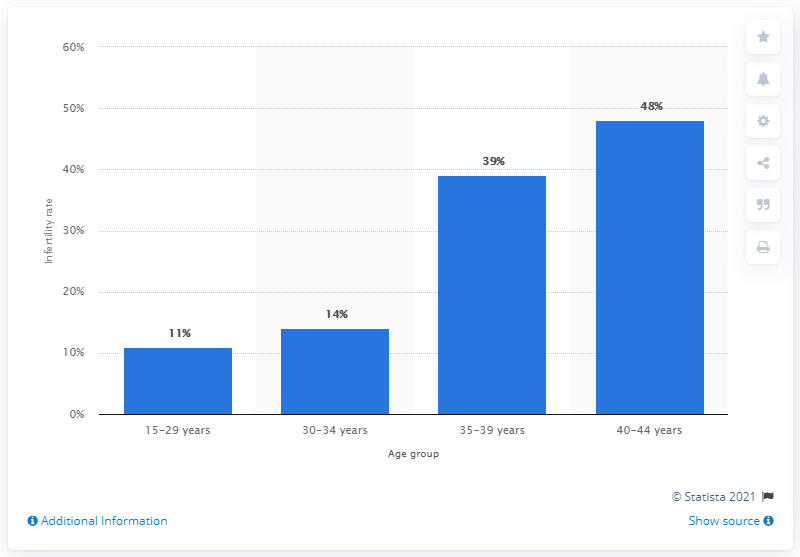List a handful of essential elements in this visual. According to the data, the infertility rate among women between the ages of 30 and 34 was 14%. 